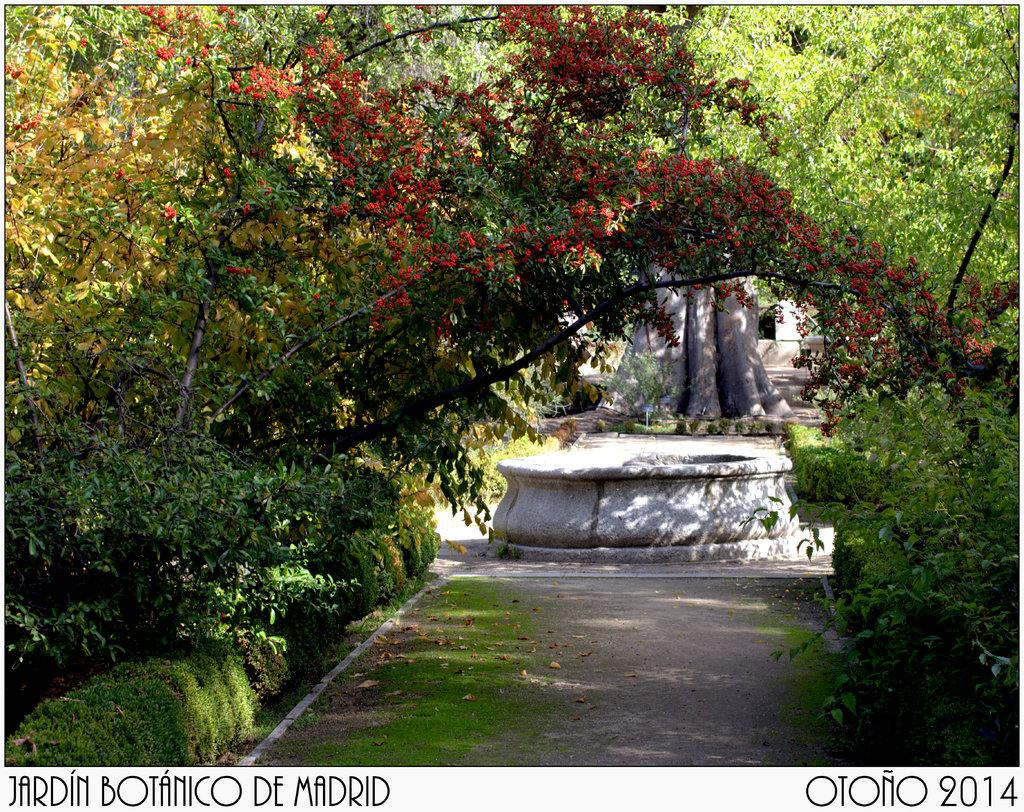What type of living organisms can be seen in the image? Plants and trees can be seen in the image. What other elements are present in the image besides the plants and trees? There are words and numbers in the image. What year is depicted in the image? There is no year present in the image; it only features plants, trees, words, and numbers. What type of behavior can be observed in the image? There is no behavior depicted in the image, as it only contains plants, trees, words, and numbers. 